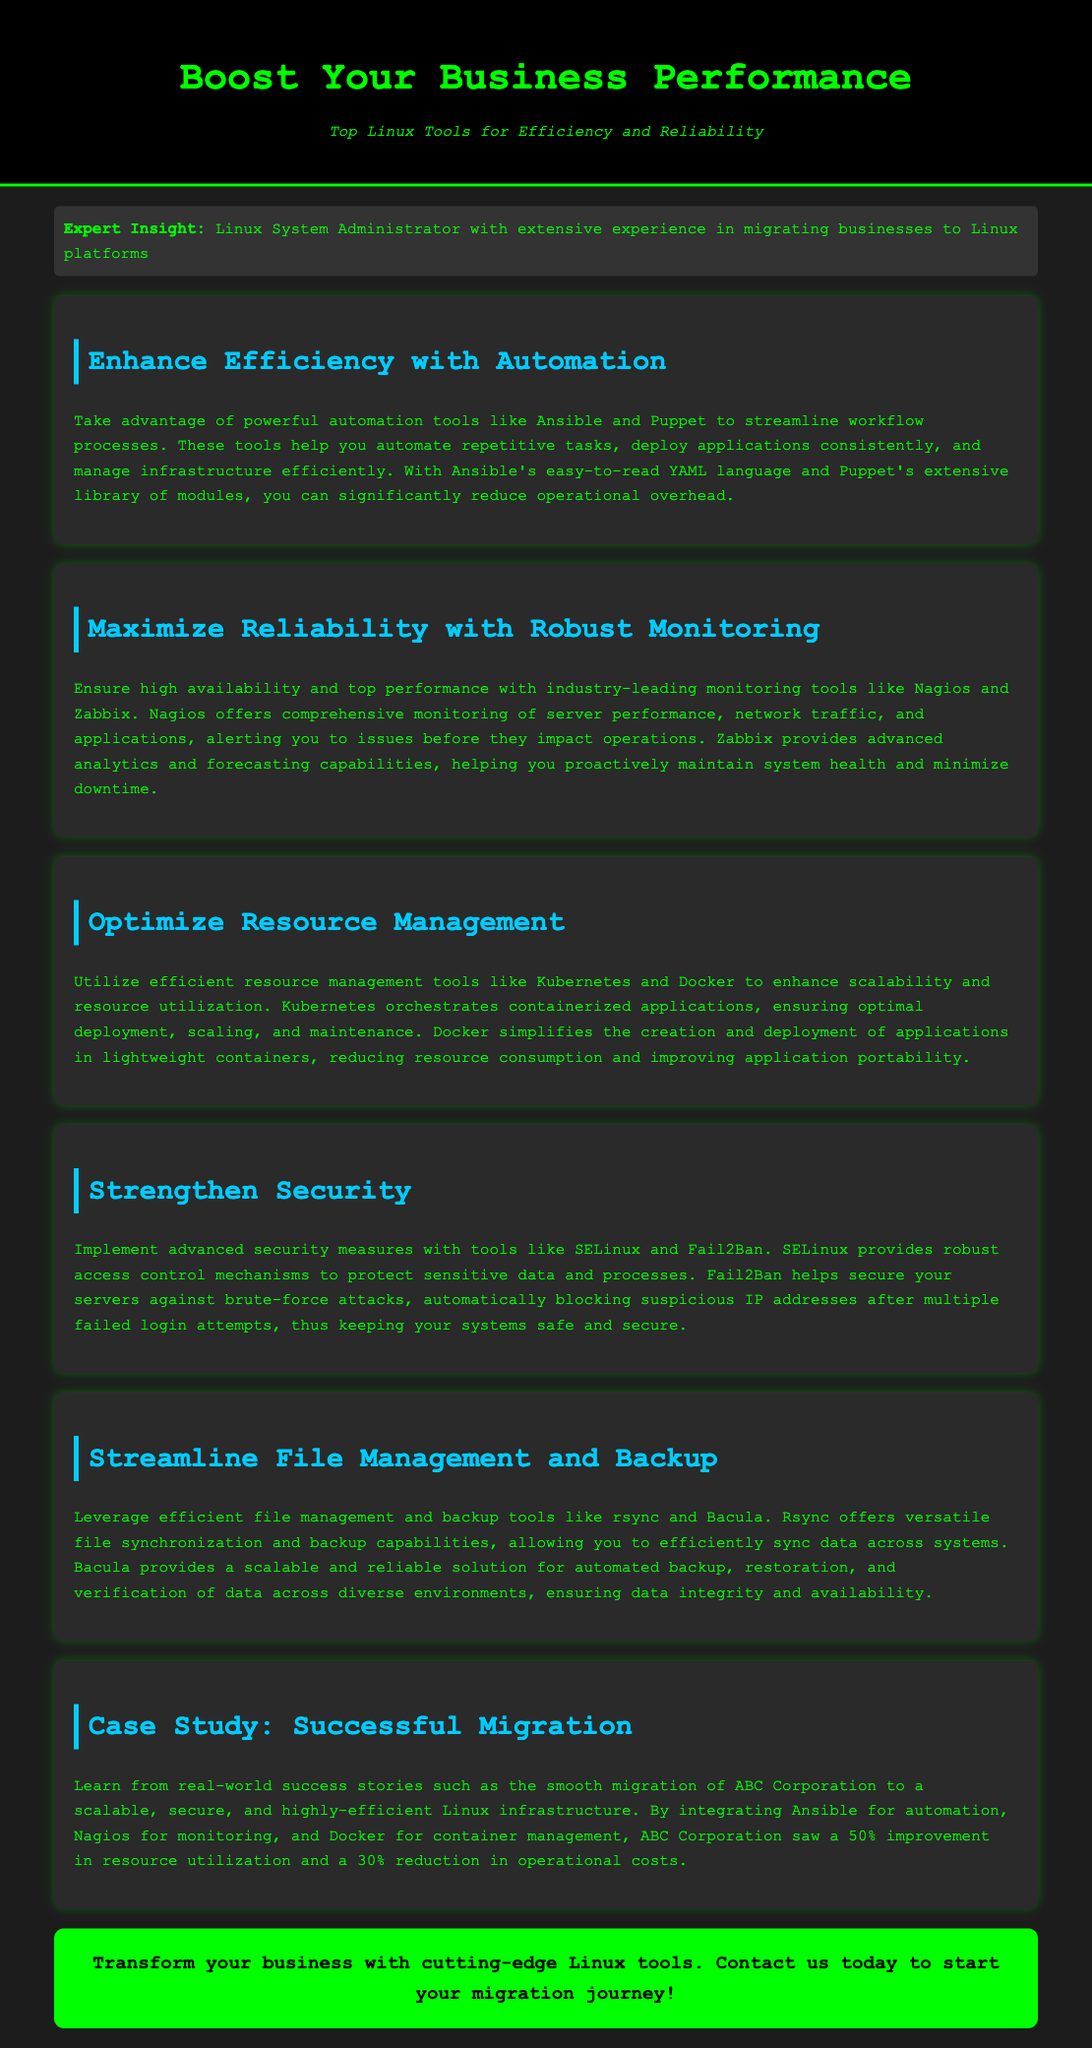What are the names of the automation tools mentioned? The automation tools listed are Ansible and Puppet, as identified in the section about enhancing efficiency.
Answer: Ansible, Puppet Which monitoring tools are highlighted for reliability? The tools mentioned in the document for monitoring and reliability are Nagios and Zabbix.
Answer: Nagios, Zabbix What has ABC Corporation achieved post-migration? The document states that ABC Corporation saw a 50% improvement in resource utilization and a 30% reduction in operational costs after the migration.
Answer: 50%, 30% What does SELinux provide? The document states that SELinux provides robust access control mechanisms aimed at protecting sensitive data and processes.
Answer: Robust access control What is the primary benefit of using Kubernetes? Kubernetes is mentioned as ensuring optimal deployment, scaling, and maintenance of containerized applications.
Answer: Optimal deployment, scaling, maintenance What type of tools are rsync and Bacula classified as? Rsync and Bacula are classified as file management and backup tools in the document.
Answer: File management and backup tools What color is used for the header background? The header background color specified in the document is black.
Answer: Black What is the call to action for the advertisement? The document encourages readers to contact for starting their migration journey with Linux tools, representing their call to action.
Answer: Contact us today to start your migration journey! 